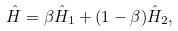<formula> <loc_0><loc_0><loc_500><loc_500>\hat { H } = \beta \hat { H } _ { 1 } + ( 1 - \beta ) \hat { H } _ { 2 } ,</formula> 